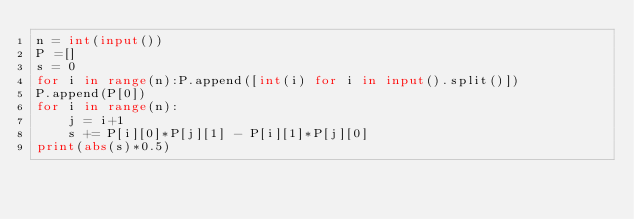<code> <loc_0><loc_0><loc_500><loc_500><_Python_>n = int(input())
P =[]
s = 0
for i in range(n):P.append([int(i) for i in input().split()])
P.append(P[0])
for i in range(n):
    j = i+1
    s += P[i][0]*P[j][1] - P[i][1]*P[j][0]
print(abs(s)*0.5)</code> 